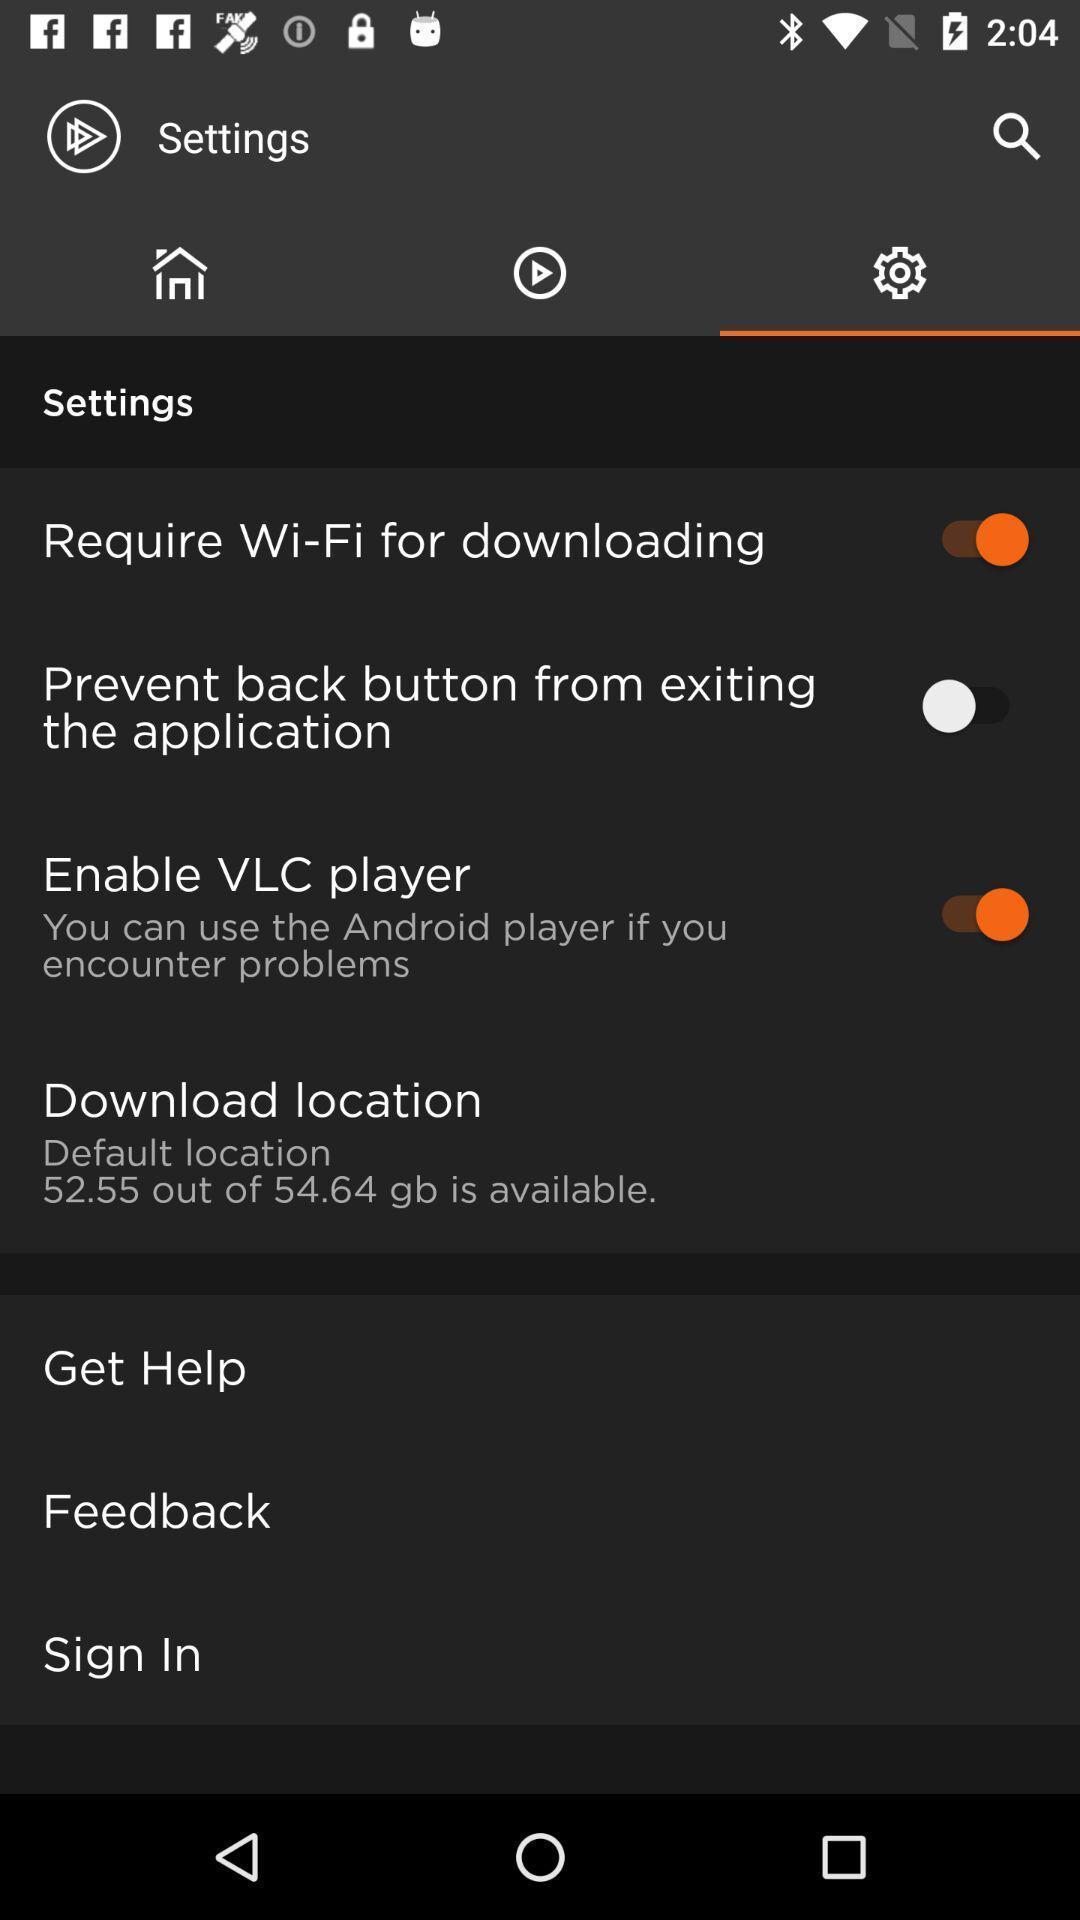Explain what's happening in this screen capture. Settings page displayed of an learning app. 